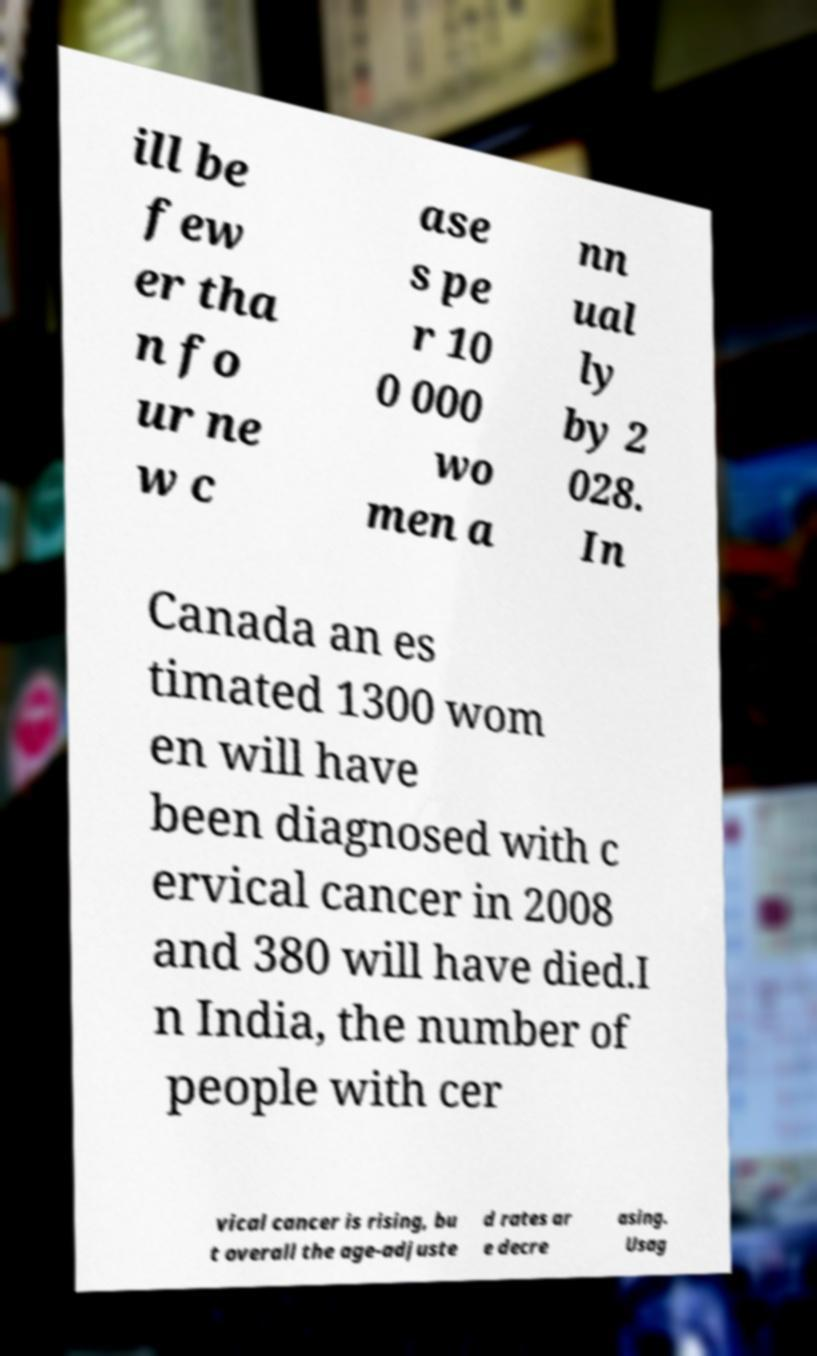Could you assist in decoding the text presented in this image and type it out clearly? ill be few er tha n fo ur ne w c ase s pe r 10 0 000 wo men a nn ual ly by 2 028. In Canada an es timated 1300 wom en will have been diagnosed with c ervical cancer in 2008 and 380 will have died.I n India, the number of people with cer vical cancer is rising, bu t overall the age-adjuste d rates ar e decre asing. Usag 